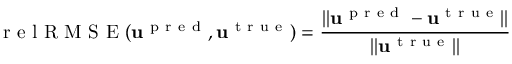<formula> <loc_0><loc_0><loc_500><loc_500>r e l R M S E ( u ^ { p r e d } , u ^ { t r u e } ) = \frac { \| u ^ { p r e d } - u ^ { t r u e } \| } { \| u ^ { t r u e } \| }</formula> 